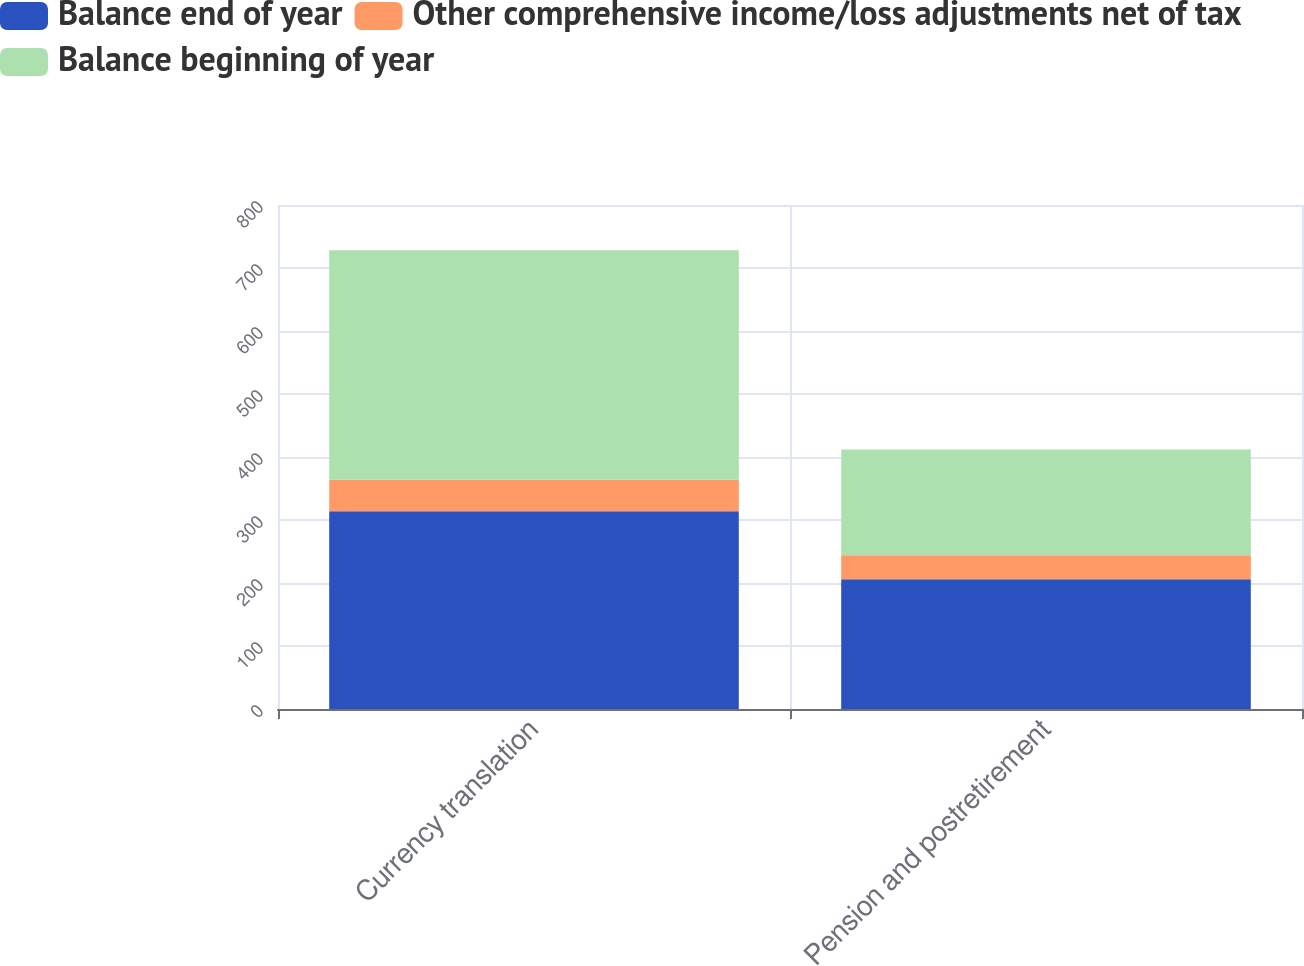<chart> <loc_0><loc_0><loc_500><loc_500><stacked_bar_chart><ecel><fcel>Currency translation<fcel>Pension and postretirement<nl><fcel>Balance end of year<fcel>314<fcel>206<nl><fcel>Other comprehensive income/loss adjustments net of tax<fcel>50<fcel>38<nl><fcel>Balance beginning of year<fcel>364<fcel>168<nl></chart> 